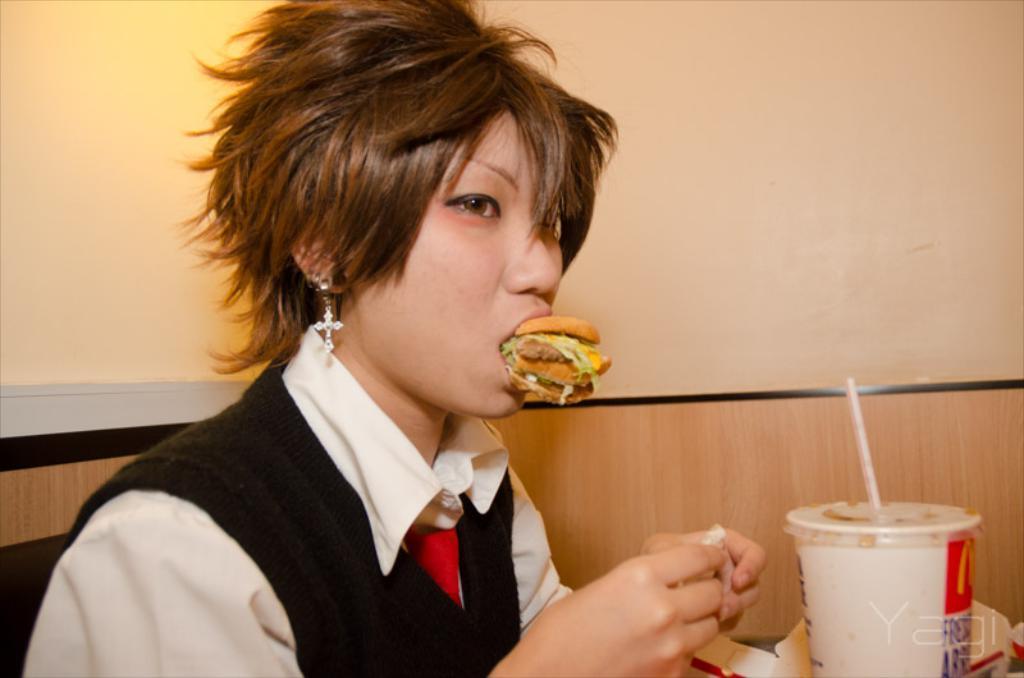Please provide a concise description of this image. In this image I can see there woman sitting and she is having food, there is a disposable cup in front of her and there is a wall in the backdrop and there is a light attached to the wall. 